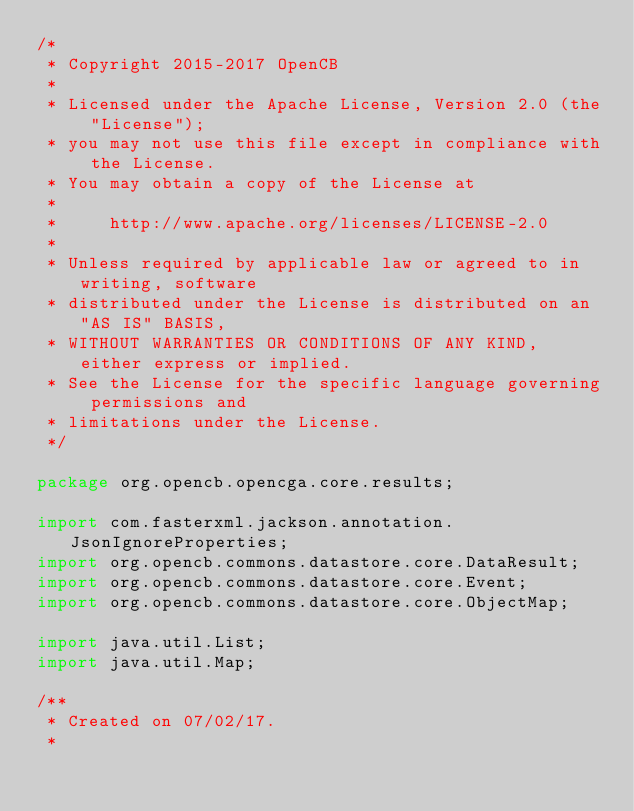Convert code to text. <code><loc_0><loc_0><loc_500><loc_500><_Java_>/*
 * Copyright 2015-2017 OpenCB
 *
 * Licensed under the Apache License, Version 2.0 (the "License");
 * you may not use this file except in compliance with the License.
 * You may obtain a copy of the License at
 *
 *     http://www.apache.org/licenses/LICENSE-2.0
 *
 * Unless required by applicable law or agreed to in writing, software
 * distributed under the License is distributed on an "AS IS" BASIS,
 * WITHOUT WARRANTIES OR CONDITIONS OF ANY KIND, either express or implied.
 * See the License for the specific language governing permissions and
 * limitations under the License.
 */

package org.opencb.opencga.core.results;

import com.fasterxml.jackson.annotation.JsonIgnoreProperties;
import org.opencb.commons.datastore.core.DataResult;
import org.opencb.commons.datastore.core.Event;
import org.opencb.commons.datastore.core.ObjectMap;

import java.util.List;
import java.util.Map;

/**
 * Created on 07/02/17.
 *</code> 